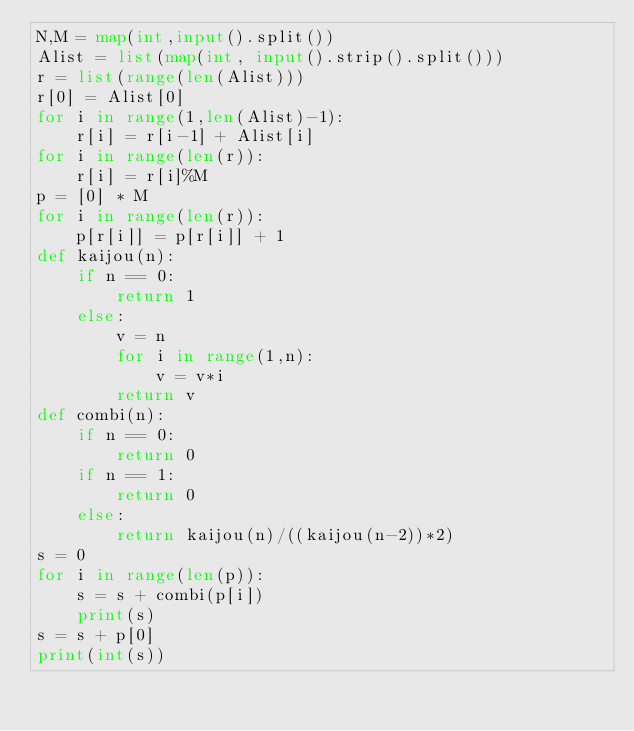<code> <loc_0><loc_0><loc_500><loc_500><_Python_>N,M = map(int,input().split())
Alist = list(map(int, input().strip().split()))
r = list(range(len(Alist)))
r[0] = Alist[0]
for i in range(1,len(Alist)-1):
    r[i] = r[i-1] + Alist[i]
for i in range(len(r)):
    r[i] = r[i]%M
p = [0] * M
for i in range(len(r)):
    p[r[i]] = p[r[i]] + 1
def kaijou(n):
    if n == 0:
        return 1
    else:
        v = n
        for i in range(1,n):
            v = v*i
        return v      
def combi(n):
    if n == 0:
        return 0
    if n == 1:
        return 0
    else:
        return kaijou(n)/((kaijou(n-2))*2)
s = 0
for i in range(len(p)):
    s = s + combi(p[i])
    print(s)
s = s + p[0]
print(int(s))</code> 